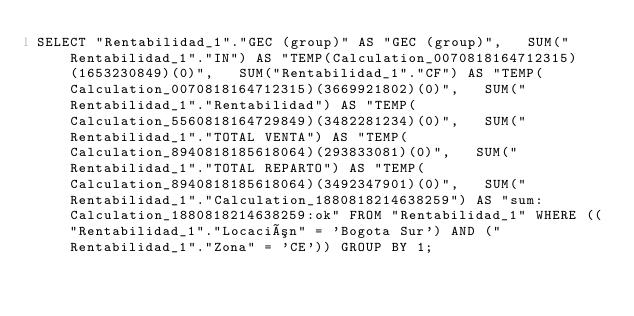<code> <loc_0><loc_0><loc_500><loc_500><_SQL_>SELECT "Rentabilidad_1"."GEC (group)" AS "GEC (group)",   SUM("Rentabilidad_1"."IN") AS "TEMP(Calculation_0070818164712315)(1653230849)(0)",   SUM("Rentabilidad_1"."CF") AS "TEMP(Calculation_0070818164712315)(3669921802)(0)",   SUM("Rentabilidad_1"."Rentabilidad") AS "TEMP(Calculation_5560818164729849)(3482281234)(0)",   SUM("Rentabilidad_1"."TOTAL VENTA") AS "TEMP(Calculation_8940818185618064)(293833081)(0)",   SUM("Rentabilidad_1"."TOTAL REPARTO") AS "TEMP(Calculation_8940818185618064)(3492347901)(0)",   SUM("Rentabilidad_1"."Calculation_1880818214638259") AS "sum:Calculation_1880818214638259:ok" FROM "Rentabilidad_1" WHERE (("Rentabilidad_1"."Locación" = 'Bogota Sur') AND ("Rentabilidad_1"."Zona" = 'CE')) GROUP BY 1;
</code> 